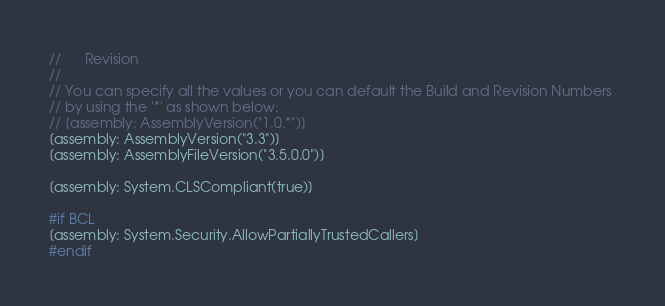Convert code to text. <code><loc_0><loc_0><loc_500><loc_500><_C#_>//      Revision
//
// You can specify all the values or you can default the Build and Revision Numbers 
// by using the '*' as shown below:
// [assembly: AssemblyVersion("1.0.*")]
[assembly: AssemblyVersion("3.3")]
[assembly: AssemblyFileVersion("3.5.0.0")]

[assembly: System.CLSCompliant(true)]

#if BCL
[assembly: System.Security.AllowPartiallyTrustedCallers]
#endif</code> 